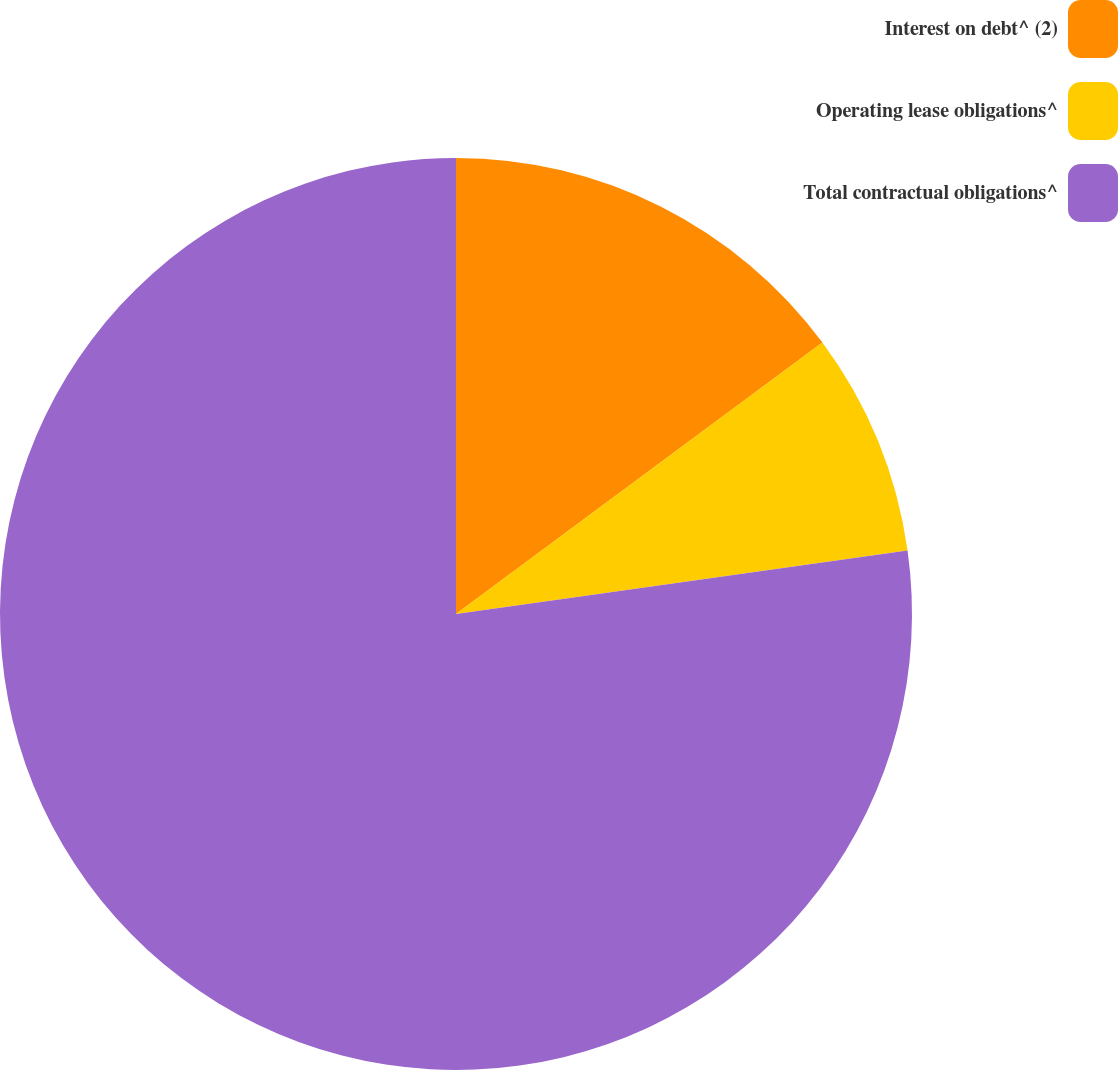<chart> <loc_0><loc_0><loc_500><loc_500><pie_chart><fcel>Interest on debt^ (2)<fcel>Operating lease obligations^<fcel>Total contractual obligations^<nl><fcel>14.85%<fcel>7.92%<fcel>77.22%<nl></chart> 